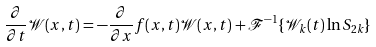<formula> <loc_0><loc_0><loc_500><loc_500>\frac { \partial } { \partial t } \mathcal { W } ( x , t ) = - \frac { \partial } { \partial x } f ( x , t ) \mathcal { W } ( x , t ) + \mathcal { F } ^ { - 1 } \{ \mathcal { W } _ { k } ( t ) \ln S _ { 2 k } \}</formula> 